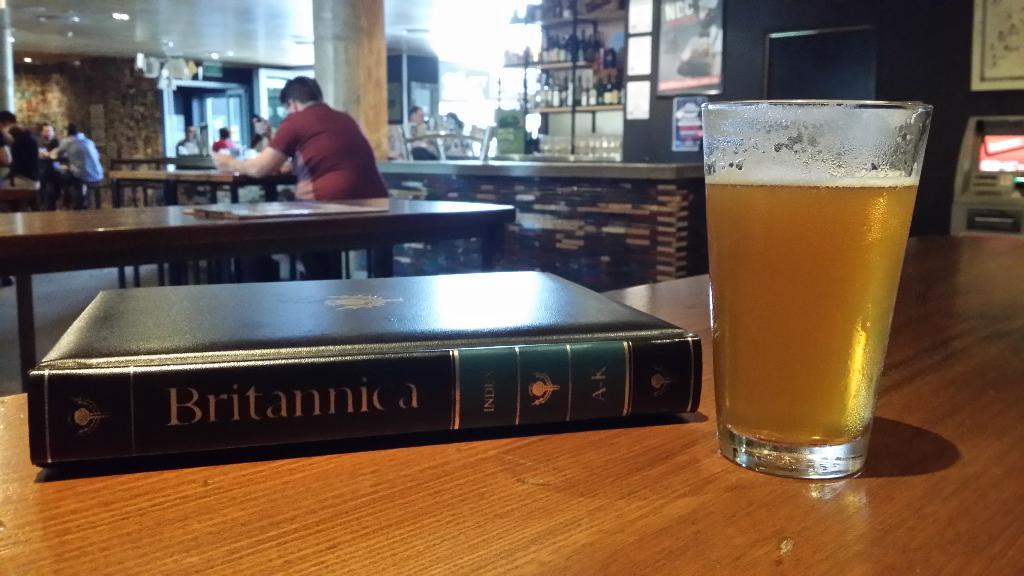Provide a one-sentence caption for the provided image. a book that has Britannica written on it. 